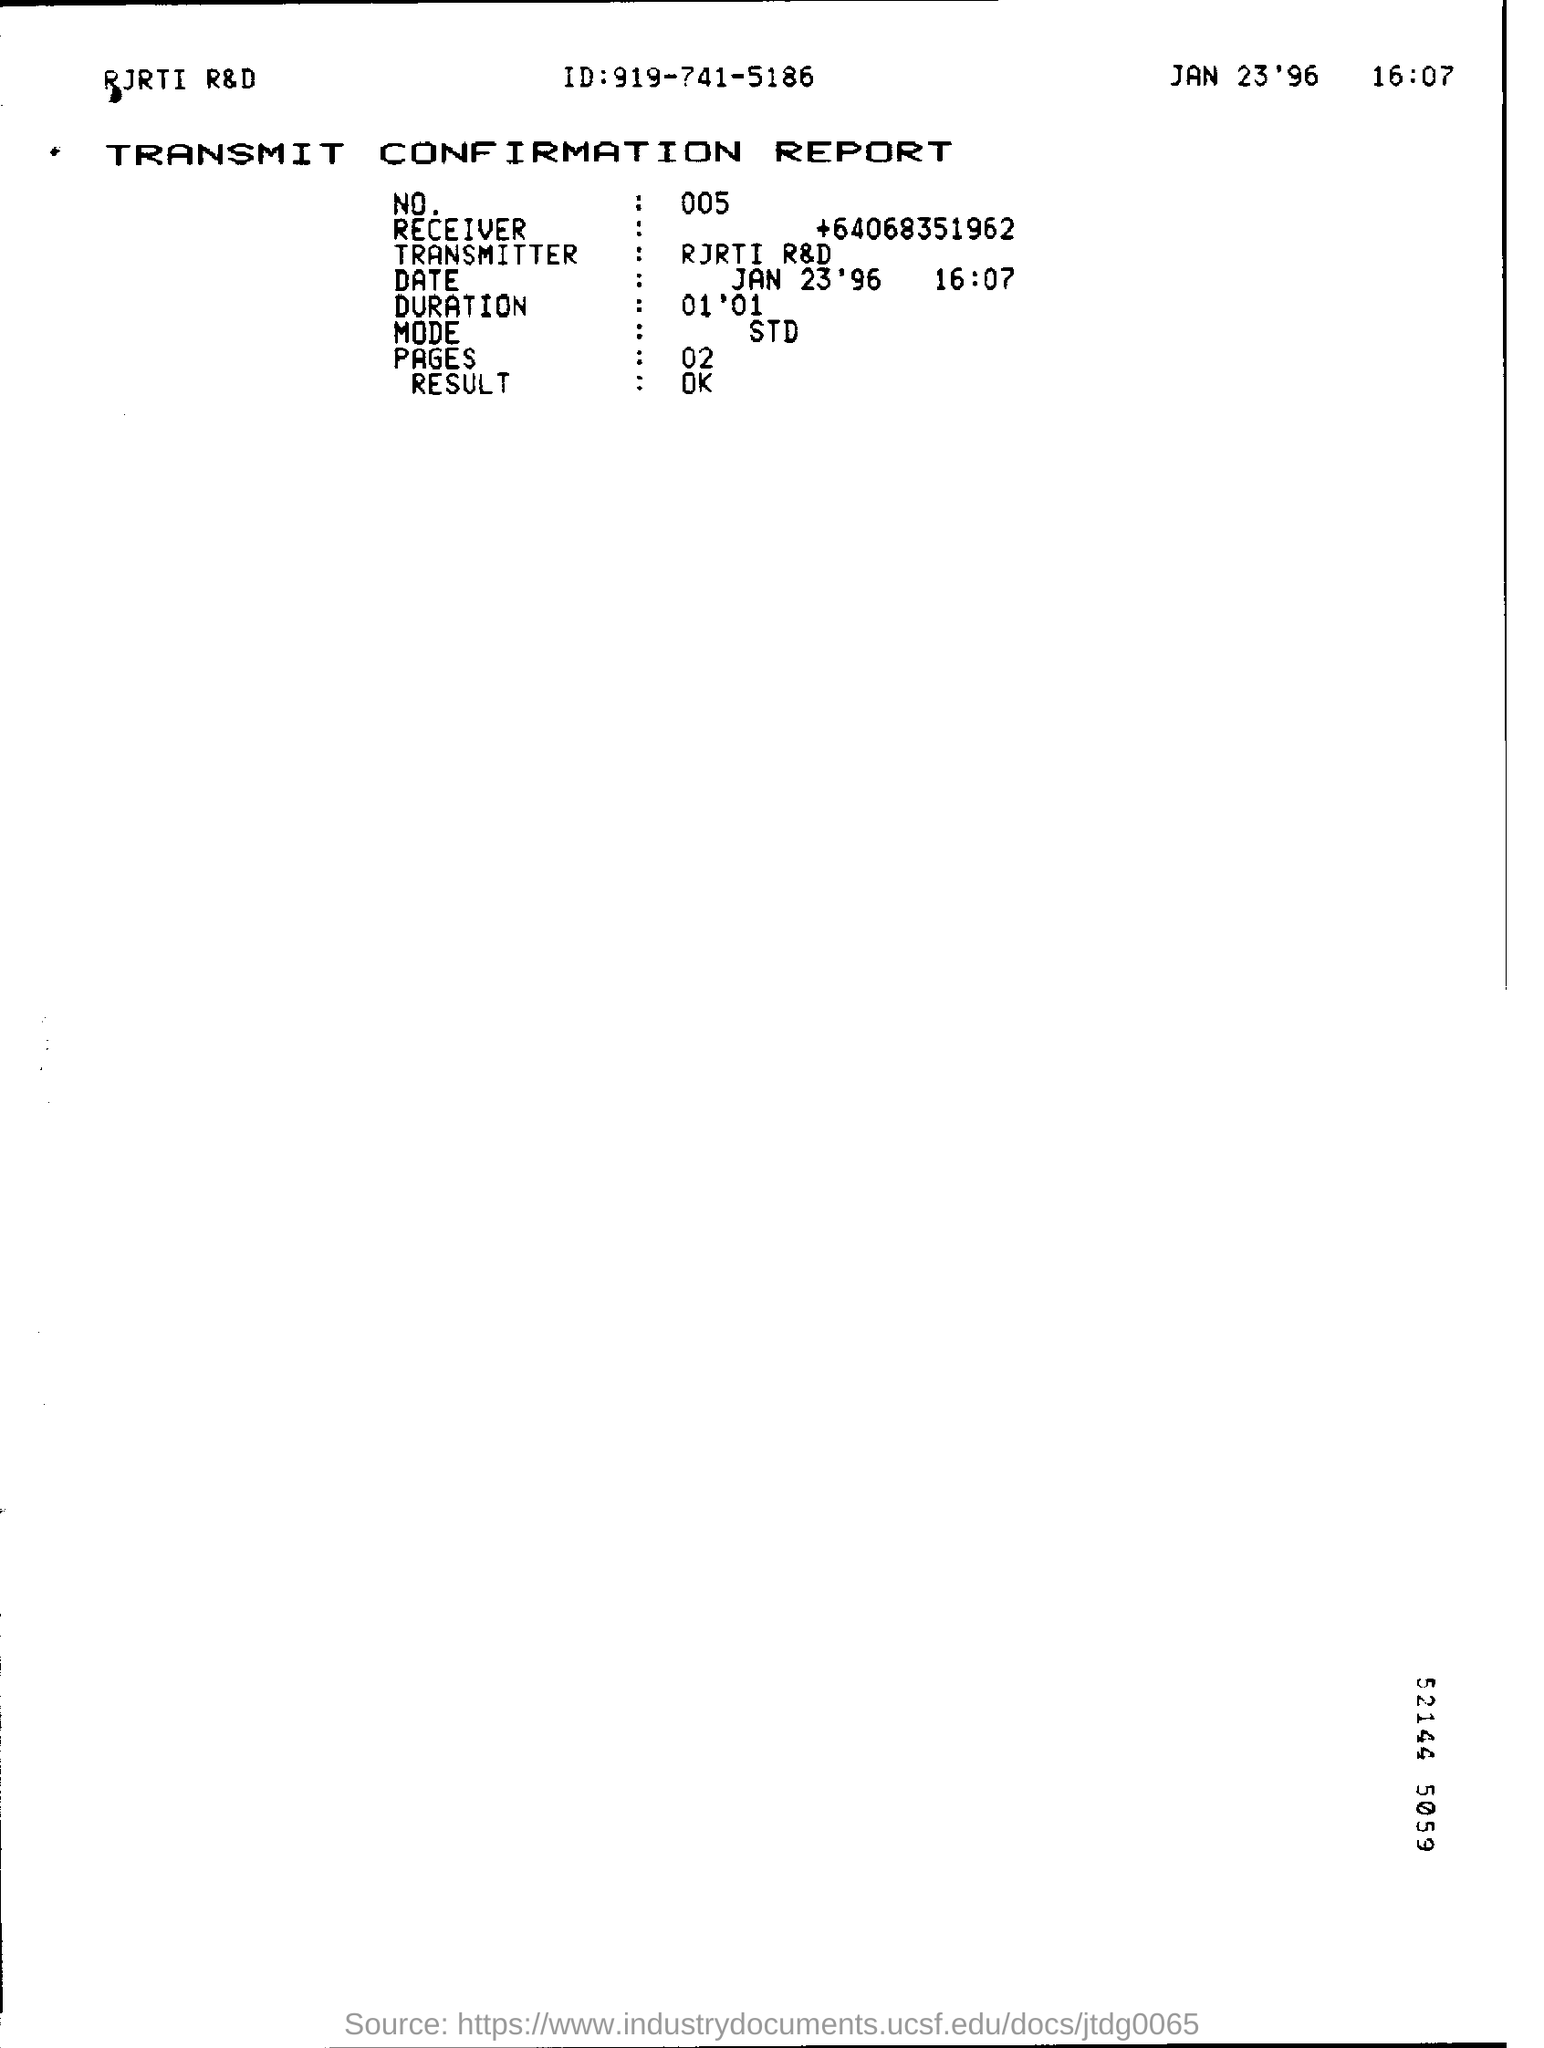Who is the Transmitter?
Ensure brevity in your answer.  RJRTI R&D. Who is the Receiver?
Ensure brevity in your answer.  +64068351962. What is the Duration?
Your response must be concise. 01 '01. What is the Mode?
Give a very brief answer. STD. What is the Result?
Your answer should be compact. OK. 